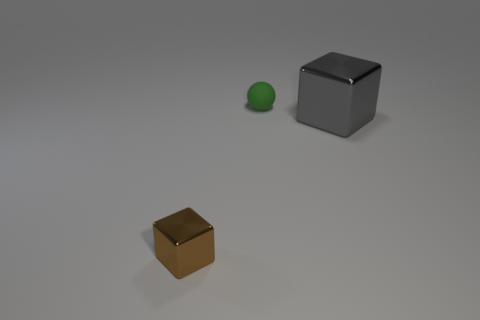Add 3 brown metal cubes. How many objects exist? 6 Subtract all gray blocks. How many blocks are left? 1 Subtract all blocks. How many objects are left? 1 Subtract all green cylinders. How many brown blocks are left? 1 Subtract 0 blue cylinders. How many objects are left? 3 Subtract all yellow balls. Subtract all green blocks. How many balls are left? 1 Subtract all green objects. Subtract all tiny brown metal cubes. How many objects are left? 1 Add 1 small cubes. How many small cubes are left? 2 Add 1 large metal spheres. How many large metal spheres exist? 1 